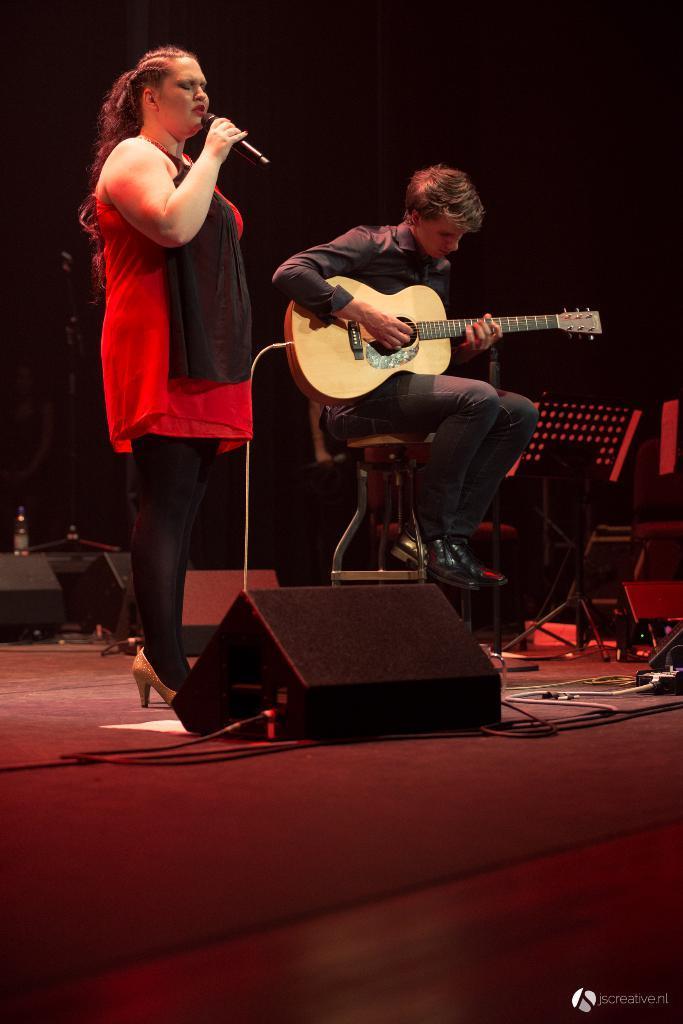How would you summarize this image in a sentence or two? The person in the left is standing and singing in front of a mic and the person in the right and playing guitar. 